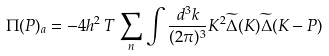<formula> <loc_0><loc_0><loc_500><loc_500>\Pi ( P ) _ { a } = - 4 h ^ { 2 } \, T \, \sum _ { n } \int \frac { d ^ { 3 } k } { ( 2 \pi ) ^ { 3 } } K ^ { 2 } \widetilde { \Delta } ( K ) \widetilde { \Delta } ( K - P )</formula> 